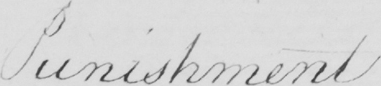Please provide the text content of this handwritten line. Punishment 